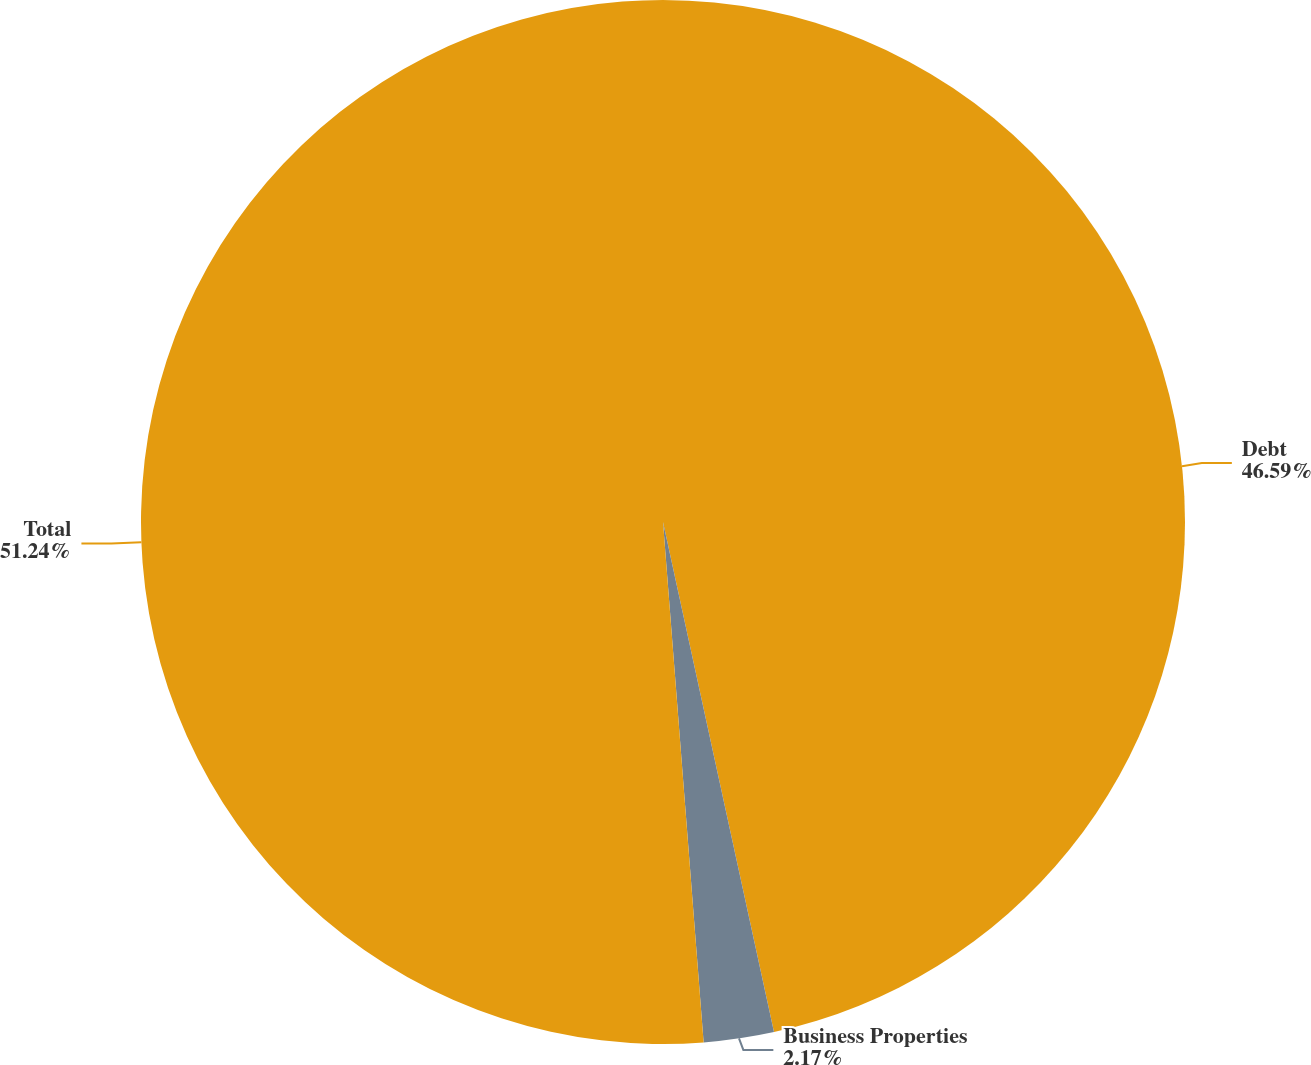Convert chart. <chart><loc_0><loc_0><loc_500><loc_500><pie_chart><fcel>Debt<fcel>Business Properties<fcel>Total<nl><fcel>46.59%<fcel>2.17%<fcel>51.24%<nl></chart> 